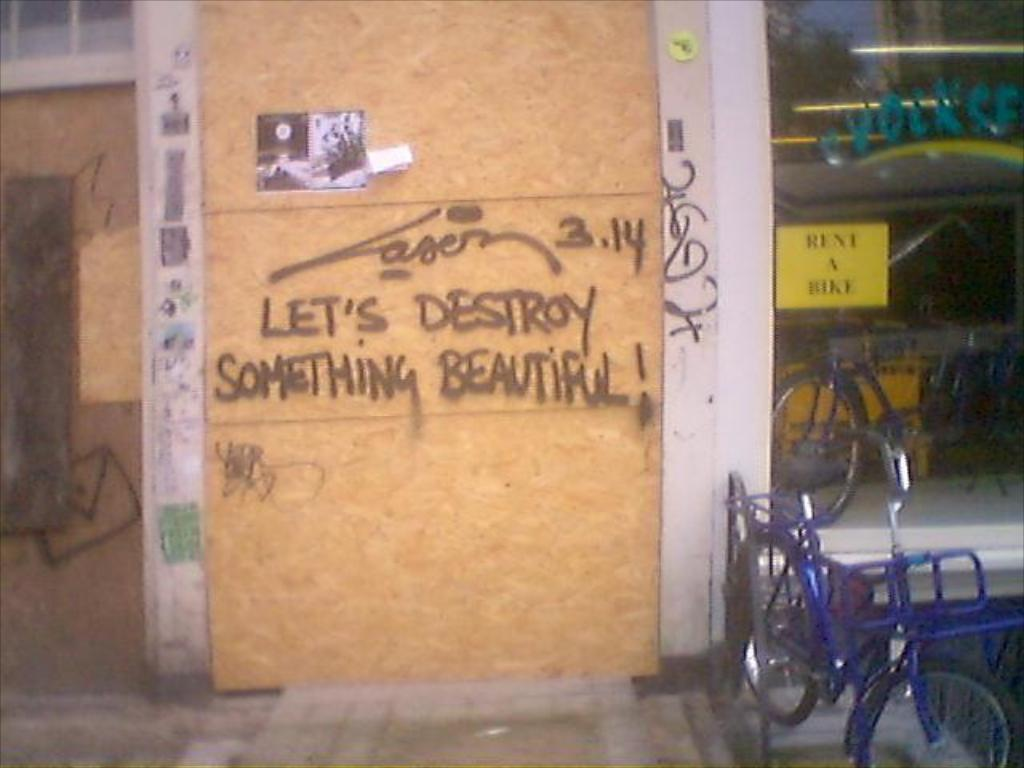What is the main object in the image? There is a board in the image. What is written or displayed on the board? There is text on the board. What can be seen in the background of the image? There is a poster on a glass door and vehicles visible in the background. What type of structure is present in the background? There is a wall in the background. What type of vegetable is being used as a decoration on the board? There is no vegetable present on the board in the image. What kind of jewel can be seen hanging from the poster on the glass door? There is no jewel visible on the poster or anywhere else in the image. 